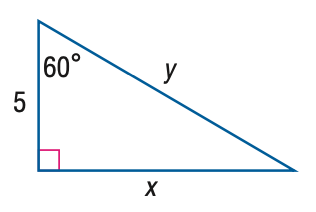Answer the mathemtical geometry problem and directly provide the correct option letter.
Question: Find x.
Choices: A: \frac { 5 } { 3 } \sqrt { 3 } B: 5 C: 5 \sqrt { 3 } D: 10 C 